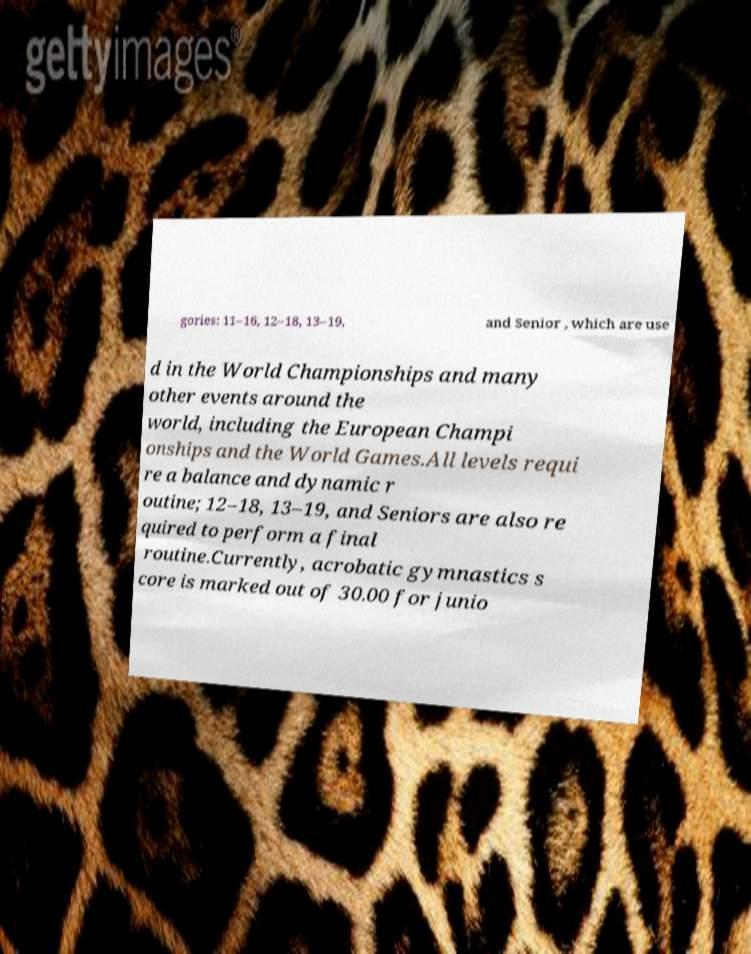There's text embedded in this image that I need extracted. Can you transcribe it verbatim? gories: 11–16, 12–18, 13–19, and Senior , which are use d in the World Championships and many other events around the world, including the European Champi onships and the World Games.All levels requi re a balance and dynamic r outine; 12–18, 13–19, and Seniors are also re quired to perform a final routine.Currently, acrobatic gymnastics s core is marked out of 30.00 for junio 